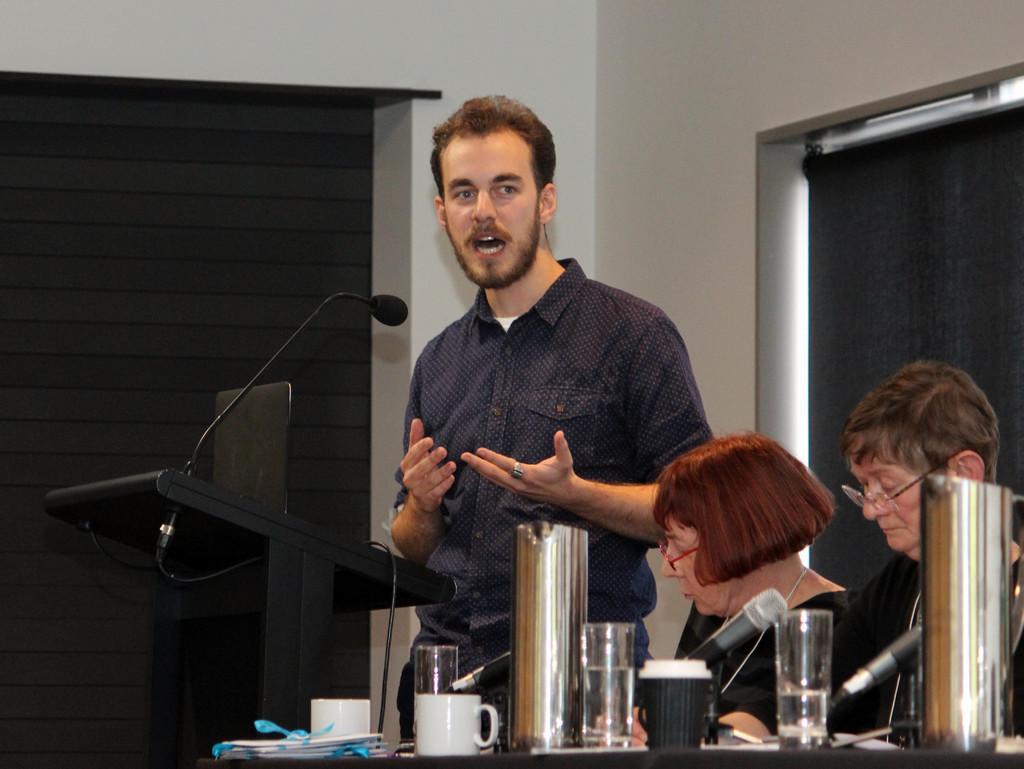Can you describe this image briefly? This image is taken indoors. In the background there is a wall with a door and a window. At the bottom of the image there is a table with many things on it. On the right side of the image two women are sitting on the chairs. In the middle of the image a man is standing and talking and there is a podium with a mic. 